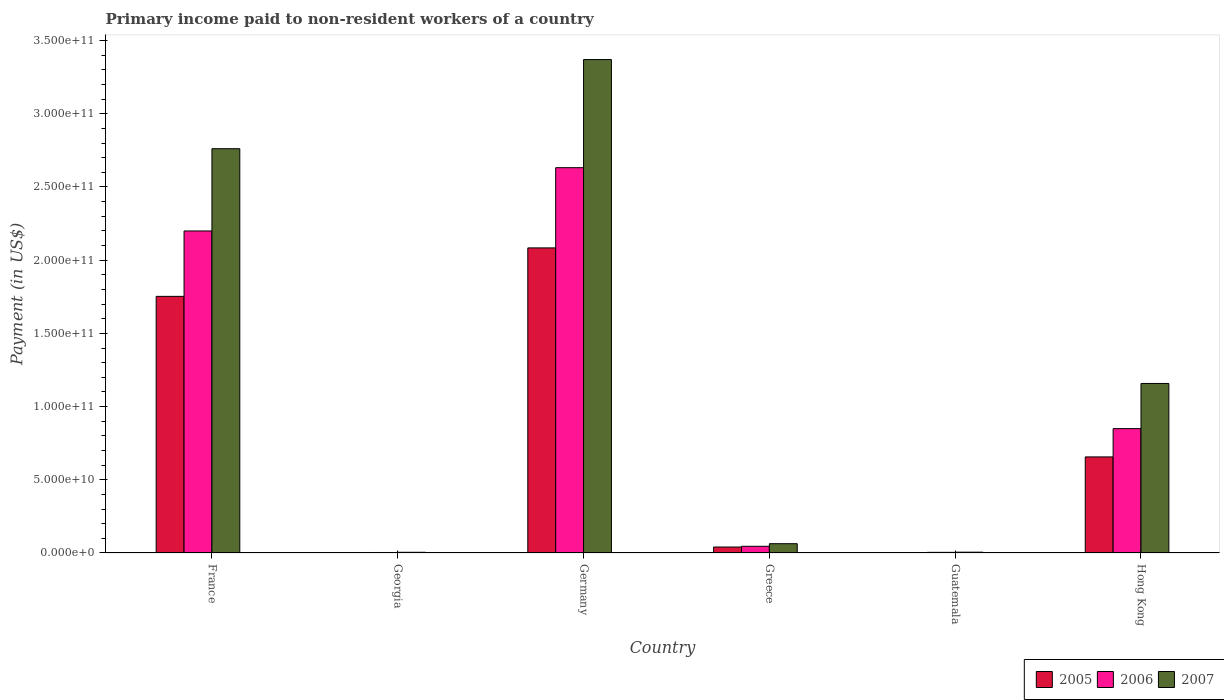How many different coloured bars are there?
Make the answer very short. 3. How many groups of bars are there?
Your answer should be compact. 6. Are the number of bars per tick equal to the number of legend labels?
Ensure brevity in your answer.  Yes. How many bars are there on the 1st tick from the left?
Ensure brevity in your answer.  3. How many bars are there on the 4th tick from the right?
Provide a succinct answer. 3. What is the label of the 5th group of bars from the left?
Ensure brevity in your answer.  Guatemala. What is the amount paid to workers in 2006 in Georgia?
Your response must be concise. 3.41e+08. Across all countries, what is the maximum amount paid to workers in 2005?
Your response must be concise. 2.08e+11. Across all countries, what is the minimum amount paid to workers in 2005?
Offer a terse response. 2.63e+08. In which country was the amount paid to workers in 2005 maximum?
Make the answer very short. Germany. In which country was the amount paid to workers in 2007 minimum?
Keep it short and to the point. Georgia. What is the total amount paid to workers in 2006 in the graph?
Your answer should be very brief. 5.73e+11. What is the difference between the amount paid to workers in 2007 in France and that in Greece?
Your response must be concise. 2.70e+11. What is the difference between the amount paid to workers in 2007 in Greece and the amount paid to workers in 2005 in Hong Kong?
Your answer should be very brief. -5.93e+1. What is the average amount paid to workers in 2006 per country?
Ensure brevity in your answer.  9.56e+1. What is the difference between the amount paid to workers of/in 2006 and amount paid to workers of/in 2007 in France?
Your answer should be compact. -5.62e+1. In how many countries, is the amount paid to workers in 2007 greater than 60000000000 US$?
Provide a succinct answer. 3. What is the ratio of the amount paid to workers in 2006 in Georgia to that in Guatemala?
Keep it short and to the point. 0.79. What is the difference between the highest and the second highest amount paid to workers in 2006?
Your response must be concise. 4.32e+1. What is the difference between the highest and the lowest amount paid to workers in 2005?
Your answer should be very brief. 2.08e+11. In how many countries, is the amount paid to workers in 2007 greater than the average amount paid to workers in 2007 taken over all countries?
Your answer should be very brief. 2. What does the 2nd bar from the right in Guatemala represents?
Offer a terse response. 2006. Is it the case that in every country, the sum of the amount paid to workers in 2005 and amount paid to workers in 2007 is greater than the amount paid to workers in 2006?
Your response must be concise. Yes. Are all the bars in the graph horizontal?
Give a very brief answer. No. Are the values on the major ticks of Y-axis written in scientific E-notation?
Make the answer very short. Yes. What is the title of the graph?
Your answer should be compact. Primary income paid to non-resident workers of a country. Does "1983" appear as one of the legend labels in the graph?
Your response must be concise. No. What is the label or title of the X-axis?
Your answer should be compact. Country. What is the label or title of the Y-axis?
Your answer should be very brief. Payment (in US$). What is the Payment (in US$) of 2005 in France?
Offer a very short reply. 1.75e+11. What is the Payment (in US$) of 2006 in France?
Your response must be concise. 2.20e+11. What is the Payment (in US$) in 2007 in France?
Offer a very short reply. 2.76e+11. What is the Payment (in US$) in 2005 in Georgia?
Make the answer very short. 2.63e+08. What is the Payment (in US$) of 2006 in Georgia?
Provide a short and direct response. 3.41e+08. What is the Payment (in US$) in 2007 in Georgia?
Offer a terse response. 4.83e+08. What is the Payment (in US$) in 2005 in Germany?
Your answer should be very brief. 2.08e+11. What is the Payment (in US$) of 2006 in Germany?
Provide a succinct answer. 2.63e+11. What is the Payment (in US$) in 2007 in Germany?
Your answer should be compact. 3.37e+11. What is the Payment (in US$) of 2005 in Greece?
Ensure brevity in your answer.  4.07e+09. What is the Payment (in US$) in 2006 in Greece?
Keep it short and to the point. 4.57e+09. What is the Payment (in US$) in 2007 in Greece?
Your response must be concise. 6.34e+09. What is the Payment (in US$) of 2005 in Guatemala?
Offer a very short reply. 3.02e+08. What is the Payment (in US$) in 2006 in Guatemala?
Your response must be concise. 4.35e+08. What is the Payment (in US$) in 2007 in Guatemala?
Your answer should be compact. 5.56e+08. What is the Payment (in US$) in 2005 in Hong Kong?
Make the answer very short. 6.56e+1. What is the Payment (in US$) of 2006 in Hong Kong?
Keep it short and to the point. 8.50e+1. What is the Payment (in US$) in 2007 in Hong Kong?
Ensure brevity in your answer.  1.16e+11. Across all countries, what is the maximum Payment (in US$) in 2005?
Your answer should be compact. 2.08e+11. Across all countries, what is the maximum Payment (in US$) of 2006?
Make the answer very short. 2.63e+11. Across all countries, what is the maximum Payment (in US$) in 2007?
Keep it short and to the point. 3.37e+11. Across all countries, what is the minimum Payment (in US$) of 2005?
Keep it short and to the point. 2.63e+08. Across all countries, what is the minimum Payment (in US$) in 2006?
Keep it short and to the point. 3.41e+08. Across all countries, what is the minimum Payment (in US$) of 2007?
Offer a very short reply. 4.83e+08. What is the total Payment (in US$) in 2005 in the graph?
Your response must be concise. 4.54e+11. What is the total Payment (in US$) in 2006 in the graph?
Make the answer very short. 5.73e+11. What is the total Payment (in US$) of 2007 in the graph?
Give a very brief answer. 7.36e+11. What is the difference between the Payment (in US$) of 2005 in France and that in Georgia?
Offer a terse response. 1.75e+11. What is the difference between the Payment (in US$) of 2006 in France and that in Georgia?
Ensure brevity in your answer.  2.20e+11. What is the difference between the Payment (in US$) of 2007 in France and that in Georgia?
Provide a succinct answer. 2.76e+11. What is the difference between the Payment (in US$) of 2005 in France and that in Germany?
Provide a succinct answer. -3.31e+1. What is the difference between the Payment (in US$) of 2006 in France and that in Germany?
Provide a succinct answer. -4.32e+1. What is the difference between the Payment (in US$) of 2007 in France and that in Germany?
Provide a short and direct response. -6.09e+1. What is the difference between the Payment (in US$) of 2005 in France and that in Greece?
Keep it short and to the point. 1.71e+11. What is the difference between the Payment (in US$) in 2006 in France and that in Greece?
Provide a short and direct response. 2.15e+11. What is the difference between the Payment (in US$) of 2007 in France and that in Greece?
Provide a short and direct response. 2.70e+11. What is the difference between the Payment (in US$) of 2005 in France and that in Guatemala?
Give a very brief answer. 1.75e+11. What is the difference between the Payment (in US$) of 2006 in France and that in Guatemala?
Make the answer very short. 2.20e+11. What is the difference between the Payment (in US$) in 2007 in France and that in Guatemala?
Your response must be concise. 2.76e+11. What is the difference between the Payment (in US$) of 2005 in France and that in Hong Kong?
Your answer should be very brief. 1.10e+11. What is the difference between the Payment (in US$) of 2006 in France and that in Hong Kong?
Offer a very short reply. 1.35e+11. What is the difference between the Payment (in US$) in 2007 in France and that in Hong Kong?
Make the answer very short. 1.60e+11. What is the difference between the Payment (in US$) of 2005 in Georgia and that in Germany?
Provide a short and direct response. -2.08e+11. What is the difference between the Payment (in US$) in 2006 in Georgia and that in Germany?
Give a very brief answer. -2.63e+11. What is the difference between the Payment (in US$) in 2007 in Georgia and that in Germany?
Your answer should be very brief. -3.37e+11. What is the difference between the Payment (in US$) in 2005 in Georgia and that in Greece?
Your response must be concise. -3.81e+09. What is the difference between the Payment (in US$) in 2006 in Georgia and that in Greece?
Provide a short and direct response. -4.22e+09. What is the difference between the Payment (in US$) in 2007 in Georgia and that in Greece?
Offer a very short reply. -5.86e+09. What is the difference between the Payment (in US$) in 2005 in Georgia and that in Guatemala?
Offer a terse response. -3.82e+07. What is the difference between the Payment (in US$) in 2006 in Georgia and that in Guatemala?
Provide a short and direct response. -9.34e+07. What is the difference between the Payment (in US$) of 2007 in Georgia and that in Guatemala?
Your answer should be compact. -7.35e+07. What is the difference between the Payment (in US$) in 2005 in Georgia and that in Hong Kong?
Your answer should be very brief. -6.54e+1. What is the difference between the Payment (in US$) in 2006 in Georgia and that in Hong Kong?
Offer a terse response. -8.46e+1. What is the difference between the Payment (in US$) in 2007 in Georgia and that in Hong Kong?
Ensure brevity in your answer.  -1.15e+11. What is the difference between the Payment (in US$) in 2005 in Germany and that in Greece?
Your response must be concise. 2.04e+11. What is the difference between the Payment (in US$) in 2006 in Germany and that in Greece?
Offer a very short reply. 2.59e+11. What is the difference between the Payment (in US$) in 2007 in Germany and that in Greece?
Offer a very short reply. 3.31e+11. What is the difference between the Payment (in US$) in 2005 in Germany and that in Guatemala?
Ensure brevity in your answer.  2.08e+11. What is the difference between the Payment (in US$) of 2006 in Germany and that in Guatemala?
Provide a short and direct response. 2.63e+11. What is the difference between the Payment (in US$) in 2007 in Germany and that in Guatemala?
Give a very brief answer. 3.36e+11. What is the difference between the Payment (in US$) of 2005 in Germany and that in Hong Kong?
Give a very brief answer. 1.43e+11. What is the difference between the Payment (in US$) of 2006 in Germany and that in Hong Kong?
Give a very brief answer. 1.78e+11. What is the difference between the Payment (in US$) in 2007 in Germany and that in Hong Kong?
Keep it short and to the point. 2.21e+11. What is the difference between the Payment (in US$) in 2005 in Greece and that in Guatemala?
Ensure brevity in your answer.  3.77e+09. What is the difference between the Payment (in US$) of 2006 in Greece and that in Guatemala?
Keep it short and to the point. 4.13e+09. What is the difference between the Payment (in US$) in 2007 in Greece and that in Guatemala?
Give a very brief answer. 5.79e+09. What is the difference between the Payment (in US$) in 2005 in Greece and that in Hong Kong?
Give a very brief answer. -6.16e+1. What is the difference between the Payment (in US$) in 2006 in Greece and that in Hong Kong?
Provide a short and direct response. -8.04e+1. What is the difference between the Payment (in US$) of 2007 in Greece and that in Hong Kong?
Your answer should be very brief. -1.09e+11. What is the difference between the Payment (in US$) in 2005 in Guatemala and that in Hong Kong?
Give a very brief answer. -6.53e+1. What is the difference between the Payment (in US$) of 2006 in Guatemala and that in Hong Kong?
Provide a succinct answer. -8.45e+1. What is the difference between the Payment (in US$) in 2007 in Guatemala and that in Hong Kong?
Give a very brief answer. -1.15e+11. What is the difference between the Payment (in US$) in 2005 in France and the Payment (in US$) in 2006 in Georgia?
Give a very brief answer. 1.75e+11. What is the difference between the Payment (in US$) in 2005 in France and the Payment (in US$) in 2007 in Georgia?
Offer a very short reply. 1.75e+11. What is the difference between the Payment (in US$) of 2006 in France and the Payment (in US$) of 2007 in Georgia?
Your answer should be compact. 2.19e+11. What is the difference between the Payment (in US$) of 2005 in France and the Payment (in US$) of 2006 in Germany?
Your answer should be very brief. -8.79e+1. What is the difference between the Payment (in US$) of 2005 in France and the Payment (in US$) of 2007 in Germany?
Your answer should be very brief. -1.62e+11. What is the difference between the Payment (in US$) in 2006 in France and the Payment (in US$) in 2007 in Germany?
Ensure brevity in your answer.  -1.17e+11. What is the difference between the Payment (in US$) of 2005 in France and the Payment (in US$) of 2006 in Greece?
Keep it short and to the point. 1.71e+11. What is the difference between the Payment (in US$) of 2005 in France and the Payment (in US$) of 2007 in Greece?
Your response must be concise. 1.69e+11. What is the difference between the Payment (in US$) of 2006 in France and the Payment (in US$) of 2007 in Greece?
Offer a very short reply. 2.14e+11. What is the difference between the Payment (in US$) in 2005 in France and the Payment (in US$) in 2006 in Guatemala?
Keep it short and to the point. 1.75e+11. What is the difference between the Payment (in US$) of 2005 in France and the Payment (in US$) of 2007 in Guatemala?
Your response must be concise. 1.75e+11. What is the difference between the Payment (in US$) in 2006 in France and the Payment (in US$) in 2007 in Guatemala?
Your answer should be compact. 2.19e+11. What is the difference between the Payment (in US$) in 2005 in France and the Payment (in US$) in 2006 in Hong Kong?
Keep it short and to the point. 9.03e+1. What is the difference between the Payment (in US$) in 2005 in France and the Payment (in US$) in 2007 in Hong Kong?
Your answer should be compact. 5.95e+1. What is the difference between the Payment (in US$) in 2006 in France and the Payment (in US$) in 2007 in Hong Kong?
Your answer should be very brief. 1.04e+11. What is the difference between the Payment (in US$) in 2005 in Georgia and the Payment (in US$) in 2006 in Germany?
Provide a succinct answer. -2.63e+11. What is the difference between the Payment (in US$) in 2005 in Georgia and the Payment (in US$) in 2007 in Germany?
Your response must be concise. -3.37e+11. What is the difference between the Payment (in US$) in 2006 in Georgia and the Payment (in US$) in 2007 in Germany?
Provide a short and direct response. -3.37e+11. What is the difference between the Payment (in US$) in 2005 in Georgia and the Payment (in US$) in 2006 in Greece?
Make the answer very short. -4.30e+09. What is the difference between the Payment (in US$) in 2005 in Georgia and the Payment (in US$) in 2007 in Greece?
Offer a very short reply. -6.08e+09. What is the difference between the Payment (in US$) of 2006 in Georgia and the Payment (in US$) of 2007 in Greece?
Give a very brief answer. -6.00e+09. What is the difference between the Payment (in US$) of 2005 in Georgia and the Payment (in US$) of 2006 in Guatemala?
Make the answer very short. -1.71e+08. What is the difference between the Payment (in US$) in 2005 in Georgia and the Payment (in US$) in 2007 in Guatemala?
Your answer should be compact. -2.93e+08. What is the difference between the Payment (in US$) in 2006 in Georgia and the Payment (in US$) in 2007 in Guatemala?
Your answer should be very brief. -2.15e+08. What is the difference between the Payment (in US$) in 2005 in Georgia and the Payment (in US$) in 2006 in Hong Kong?
Provide a short and direct response. -8.47e+1. What is the difference between the Payment (in US$) in 2005 in Georgia and the Payment (in US$) in 2007 in Hong Kong?
Offer a very short reply. -1.16e+11. What is the difference between the Payment (in US$) in 2006 in Georgia and the Payment (in US$) in 2007 in Hong Kong?
Ensure brevity in your answer.  -1.15e+11. What is the difference between the Payment (in US$) in 2005 in Germany and the Payment (in US$) in 2006 in Greece?
Ensure brevity in your answer.  2.04e+11. What is the difference between the Payment (in US$) in 2005 in Germany and the Payment (in US$) in 2007 in Greece?
Keep it short and to the point. 2.02e+11. What is the difference between the Payment (in US$) in 2006 in Germany and the Payment (in US$) in 2007 in Greece?
Keep it short and to the point. 2.57e+11. What is the difference between the Payment (in US$) in 2005 in Germany and the Payment (in US$) in 2006 in Guatemala?
Offer a terse response. 2.08e+11. What is the difference between the Payment (in US$) in 2005 in Germany and the Payment (in US$) in 2007 in Guatemala?
Offer a very short reply. 2.08e+11. What is the difference between the Payment (in US$) of 2006 in Germany and the Payment (in US$) of 2007 in Guatemala?
Your answer should be compact. 2.63e+11. What is the difference between the Payment (in US$) of 2005 in Germany and the Payment (in US$) of 2006 in Hong Kong?
Make the answer very short. 1.23e+11. What is the difference between the Payment (in US$) of 2005 in Germany and the Payment (in US$) of 2007 in Hong Kong?
Give a very brief answer. 9.26e+1. What is the difference between the Payment (in US$) in 2006 in Germany and the Payment (in US$) in 2007 in Hong Kong?
Give a very brief answer. 1.47e+11. What is the difference between the Payment (in US$) in 2005 in Greece and the Payment (in US$) in 2006 in Guatemala?
Your answer should be very brief. 3.64e+09. What is the difference between the Payment (in US$) in 2005 in Greece and the Payment (in US$) in 2007 in Guatemala?
Your response must be concise. 3.52e+09. What is the difference between the Payment (in US$) in 2006 in Greece and the Payment (in US$) in 2007 in Guatemala?
Offer a very short reply. 4.01e+09. What is the difference between the Payment (in US$) of 2005 in Greece and the Payment (in US$) of 2006 in Hong Kong?
Your response must be concise. -8.09e+1. What is the difference between the Payment (in US$) in 2005 in Greece and the Payment (in US$) in 2007 in Hong Kong?
Offer a very short reply. -1.12e+11. What is the difference between the Payment (in US$) in 2006 in Greece and the Payment (in US$) in 2007 in Hong Kong?
Your response must be concise. -1.11e+11. What is the difference between the Payment (in US$) in 2005 in Guatemala and the Payment (in US$) in 2006 in Hong Kong?
Offer a terse response. -8.47e+1. What is the difference between the Payment (in US$) in 2005 in Guatemala and the Payment (in US$) in 2007 in Hong Kong?
Your answer should be compact. -1.15e+11. What is the difference between the Payment (in US$) of 2006 in Guatemala and the Payment (in US$) of 2007 in Hong Kong?
Ensure brevity in your answer.  -1.15e+11. What is the average Payment (in US$) in 2005 per country?
Offer a terse response. 7.57e+1. What is the average Payment (in US$) in 2006 per country?
Your answer should be very brief. 9.56e+1. What is the average Payment (in US$) in 2007 per country?
Keep it short and to the point. 1.23e+11. What is the difference between the Payment (in US$) of 2005 and Payment (in US$) of 2006 in France?
Offer a very short reply. -4.47e+1. What is the difference between the Payment (in US$) of 2005 and Payment (in US$) of 2007 in France?
Provide a short and direct response. -1.01e+11. What is the difference between the Payment (in US$) in 2006 and Payment (in US$) in 2007 in France?
Provide a short and direct response. -5.62e+1. What is the difference between the Payment (in US$) in 2005 and Payment (in US$) in 2006 in Georgia?
Your response must be concise. -7.79e+07. What is the difference between the Payment (in US$) in 2005 and Payment (in US$) in 2007 in Georgia?
Keep it short and to the point. -2.19e+08. What is the difference between the Payment (in US$) of 2006 and Payment (in US$) of 2007 in Georgia?
Make the answer very short. -1.41e+08. What is the difference between the Payment (in US$) of 2005 and Payment (in US$) of 2006 in Germany?
Give a very brief answer. -5.48e+1. What is the difference between the Payment (in US$) in 2005 and Payment (in US$) in 2007 in Germany?
Your answer should be very brief. -1.29e+11. What is the difference between the Payment (in US$) in 2006 and Payment (in US$) in 2007 in Germany?
Your answer should be very brief. -7.39e+1. What is the difference between the Payment (in US$) of 2005 and Payment (in US$) of 2006 in Greece?
Your response must be concise. -4.95e+08. What is the difference between the Payment (in US$) of 2005 and Payment (in US$) of 2007 in Greece?
Ensure brevity in your answer.  -2.27e+09. What is the difference between the Payment (in US$) in 2006 and Payment (in US$) in 2007 in Greece?
Ensure brevity in your answer.  -1.78e+09. What is the difference between the Payment (in US$) in 2005 and Payment (in US$) in 2006 in Guatemala?
Make the answer very short. -1.33e+08. What is the difference between the Payment (in US$) in 2005 and Payment (in US$) in 2007 in Guatemala?
Your response must be concise. -2.54e+08. What is the difference between the Payment (in US$) in 2006 and Payment (in US$) in 2007 in Guatemala?
Offer a very short reply. -1.21e+08. What is the difference between the Payment (in US$) in 2005 and Payment (in US$) in 2006 in Hong Kong?
Keep it short and to the point. -1.93e+1. What is the difference between the Payment (in US$) of 2005 and Payment (in US$) of 2007 in Hong Kong?
Offer a terse response. -5.02e+1. What is the difference between the Payment (in US$) of 2006 and Payment (in US$) of 2007 in Hong Kong?
Offer a terse response. -3.08e+1. What is the ratio of the Payment (in US$) of 2005 in France to that in Georgia?
Your answer should be very brief. 665.66. What is the ratio of the Payment (in US$) of 2006 in France to that in Georgia?
Your answer should be compact. 644.61. What is the ratio of the Payment (in US$) in 2007 in France to that in Georgia?
Give a very brief answer. 572.29. What is the ratio of the Payment (in US$) in 2005 in France to that in Germany?
Your answer should be compact. 0.84. What is the ratio of the Payment (in US$) in 2006 in France to that in Germany?
Offer a terse response. 0.84. What is the ratio of the Payment (in US$) in 2007 in France to that in Germany?
Offer a terse response. 0.82. What is the ratio of the Payment (in US$) of 2005 in France to that in Greece?
Make the answer very short. 43.05. What is the ratio of the Payment (in US$) of 2006 in France to that in Greece?
Your answer should be very brief. 48.17. What is the ratio of the Payment (in US$) of 2007 in France to that in Greece?
Keep it short and to the point. 43.52. What is the ratio of the Payment (in US$) in 2005 in France to that in Guatemala?
Make the answer very short. 581.38. What is the ratio of the Payment (in US$) in 2006 in France to that in Guatemala?
Your answer should be very brief. 506.1. What is the ratio of the Payment (in US$) of 2007 in France to that in Guatemala?
Provide a short and direct response. 496.65. What is the ratio of the Payment (in US$) in 2005 in France to that in Hong Kong?
Provide a short and direct response. 2.67. What is the ratio of the Payment (in US$) of 2006 in France to that in Hong Kong?
Make the answer very short. 2.59. What is the ratio of the Payment (in US$) of 2007 in France to that in Hong Kong?
Offer a very short reply. 2.38. What is the ratio of the Payment (in US$) of 2005 in Georgia to that in Germany?
Make the answer very short. 0. What is the ratio of the Payment (in US$) in 2006 in Georgia to that in Germany?
Your response must be concise. 0. What is the ratio of the Payment (in US$) of 2007 in Georgia to that in Germany?
Ensure brevity in your answer.  0. What is the ratio of the Payment (in US$) in 2005 in Georgia to that in Greece?
Your answer should be compact. 0.06. What is the ratio of the Payment (in US$) of 2006 in Georgia to that in Greece?
Ensure brevity in your answer.  0.07. What is the ratio of the Payment (in US$) in 2007 in Georgia to that in Greece?
Your response must be concise. 0.08. What is the ratio of the Payment (in US$) of 2005 in Georgia to that in Guatemala?
Offer a terse response. 0.87. What is the ratio of the Payment (in US$) of 2006 in Georgia to that in Guatemala?
Give a very brief answer. 0.79. What is the ratio of the Payment (in US$) of 2007 in Georgia to that in Guatemala?
Offer a terse response. 0.87. What is the ratio of the Payment (in US$) of 2005 in Georgia to that in Hong Kong?
Offer a very short reply. 0. What is the ratio of the Payment (in US$) of 2006 in Georgia to that in Hong Kong?
Provide a short and direct response. 0. What is the ratio of the Payment (in US$) of 2007 in Georgia to that in Hong Kong?
Make the answer very short. 0. What is the ratio of the Payment (in US$) in 2005 in Germany to that in Greece?
Make the answer very short. 51.18. What is the ratio of the Payment (in US$) in 2006 in Germany to that in Greece?
Your answer should be very brief. 57.64. What is the ratio of the Payment (in US$) in 2007 in Germany to that in Greece?
Provide a short and direct response. 53.12. What is the ratio of the Payment (in US$) in 2005 in Germany to that in Guatemala?
Offer a terse response. 691.18. What is the ratio of the Payment (in US$) of 2006 in Germany to that in Guatemala?
Offer a very short reply. 605.58. What is the ratio of the Payment (in US$) of 2007 in Germany to that in Guatemala?
Provide a short and direct response. 606.19. What is the ratio of the Payment (in US$) in 2005 in Germany to that in Hong Kong?
Offer a very short reply. 3.18. What is the ratio of the Payment (in US$) in 2006 in Germany to that in Hong Kong?
Offer a very short reply. 3.1. What is the ratio of the Payment (in US$) in 2007 in Germany to that in Hong Kong?
Your answer should be compact. 2.91. What is the ratio of the Payment (in US$) of 2005 in Greece to that in Guatemala?
Offer a terse response. 13.5. What is the ratio of the Payment (in US$) of 2006 in Greece to that in Guatemala?
Provide a succinct answer. 10.51. What is the ratio of the Payment (in US$) of 2007 in Greece to that in Guatemala?
Offer a terse response. 11.41. What is the ratio of the Payment (in US$) in 2005 in Greece to that in Hong Kong?
Offer a very short reply. 0.06. What is the ratio of the Payment (in US$) in 2006 in Greece to that in Hong Kong?
Give a very brief answer. 0.05. What is the ratio of the Payment (in US$) in 2007 in Greece to that in Hong Kong?
Provide a succinct answer. 0.05. What is the ratio of the Payment (in US$) of 2005 in Guatemala to that in Hong Kong?
Offer a terse response. 0. What is the ratio of the Payment (in US$) of 2006 in Guatemala to that in Hong Kong?
Make the answer very short. 0.01. What is the ratio of the Payment (in US$) in 2007 in Guatemala to that in Hong Kong?
Your answer should be compact. 0. What is the difference between the highest and the second highest Payment (in US$) of 2005?
Offer a very short reply. 3.31e+1. What is the difference between the highest and the second highest Payment (in US$) of 2006?
Your answer should be compact. 4.32e+1. What is the difference between the highest and the second highest Payment (in US$) in 2007?
Your response must be concise. 6.09e+1. What is the difference between the highest and the lowest Payment (in US$) of 2005?
Your answer should be very brief. 2.08e+11. What is the difference between the highest and the lowest Payment (in US$) in 2006?
Provide a short and direct response. 2.63e+11. What is the difference between the highest and the lowest Payment (in US$) of 2007?
Your response must be concise. 3.37e+11. 